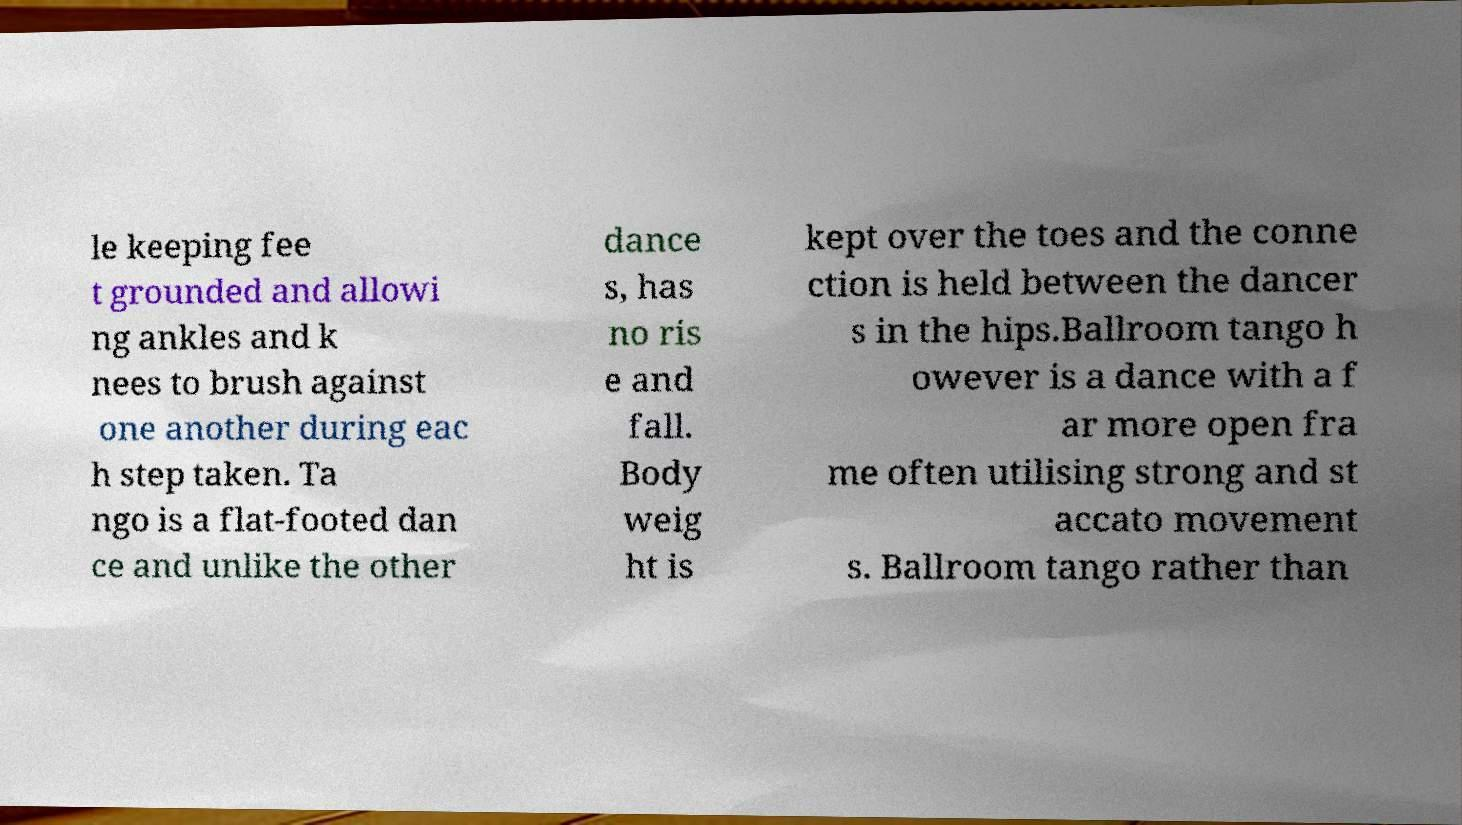Please read and relay the text visible in this image. What does it say? le keeping fee t grounded and allowi ng ankles and k nees to brush against one another during eac h step taken. Ta ngo is a flat-footed dan ce and unlike the other dance s, has no ris e and fall. Body weig ht is kept over the toes and the conne ction is held between the dancer s in the hips.Ballroom tango h owever is a dance with a f ar more open fra me often utilising strong and st accato movement s. Ballroom tango rather than 